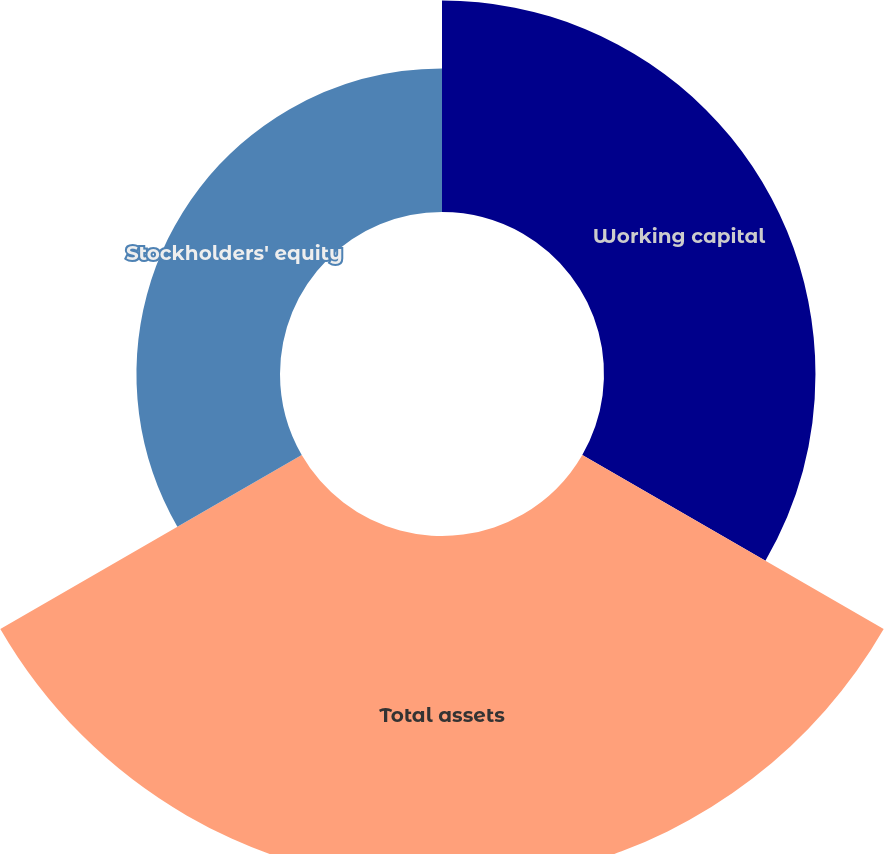<chart> <loc_0><loc_0><loc_500><loc_500><pie_chart><fcel>Working capital<fcel>Total assets<fcel>Stockholders' equity<nl><fcel>30.08%<fcel>49.5%<fcel>20.42%<nl></chart> 